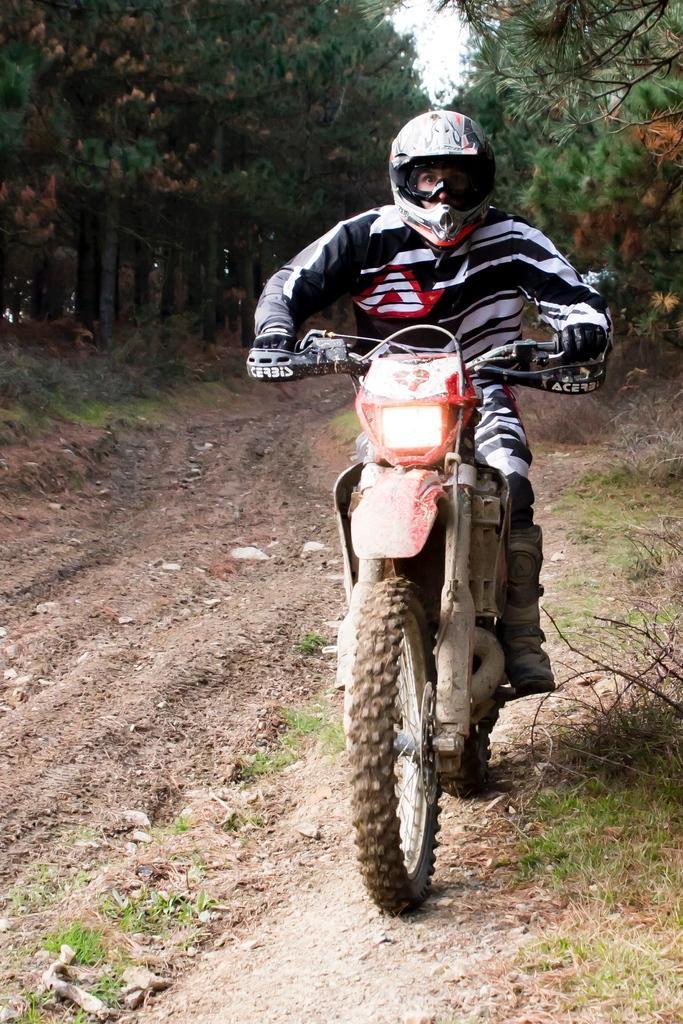Can you describe this image briefly? At the center of the image there is a person riding a bike on a road. On the right and left side of the road there are some trees. 